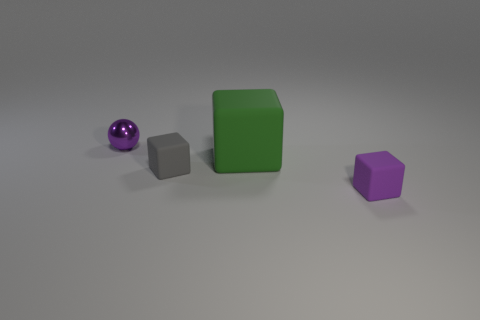Add 1 tiny purple metallic things. How many objects exist? 5 Subtract all cubes. How many objects are left? 1 Subtract 0 brown balls. How many objects are left? 4 Subtract all small shiny cubes. Subtract all gray matte cubes. How many objects are left? 3 Add 4 green matte objects. How many green matte objects are left? 5 Add 1 large cyan cylinders. How many large cyan cylinders exist? 1 